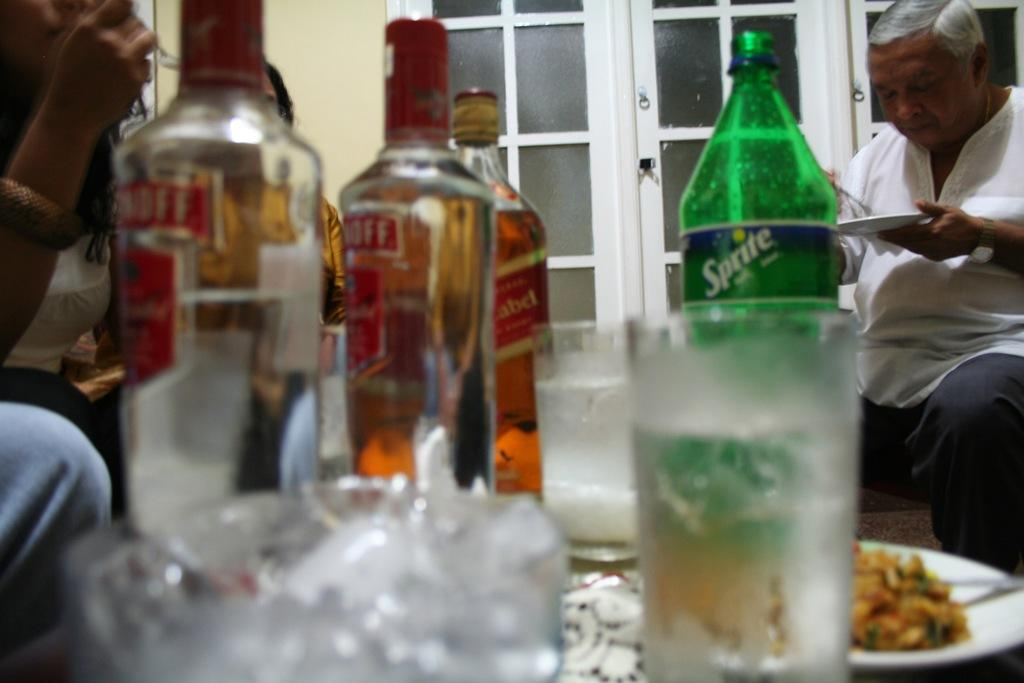<image>
Give a short and clear explanation of the subsequent image. A bottle of sprite is on a table with several bottles of alcohol. 